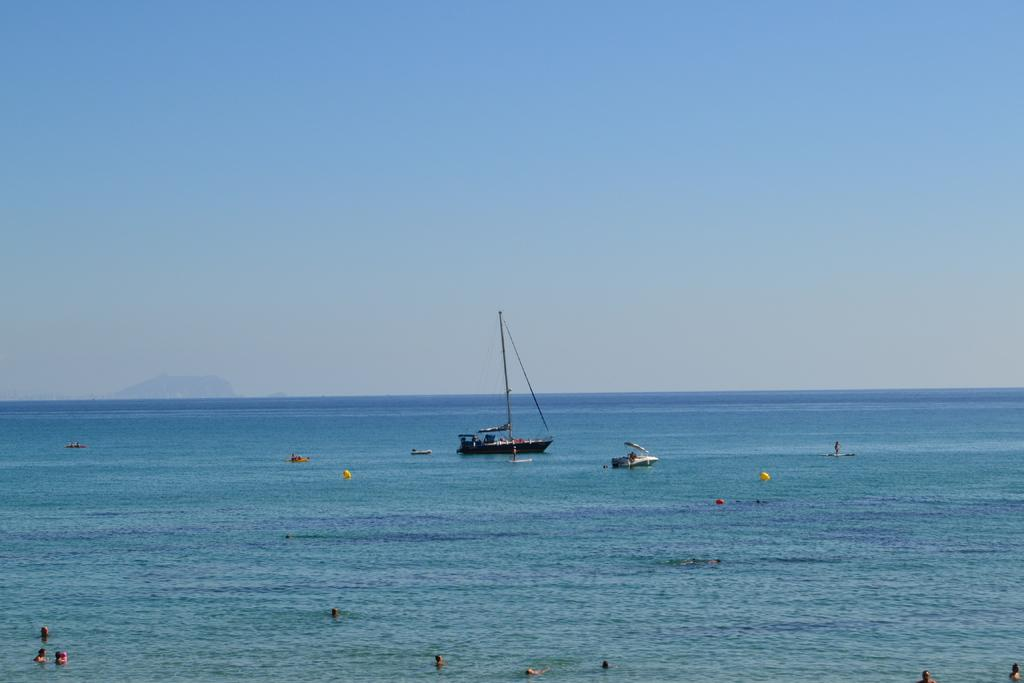Where was the image taken? The image is clicked outside the city. What can be seen in the foreground of the image? There is a group of people in the foreground. What is the location of the group of people in the image? The group of people is in a water body. What else can be seen in the image? There are boats in the center of the image. What is visible in the background of the image? The sky is visible in the background. How many dogs are present in the image? There are no dogs present in the image. What type of root can be seen growing near the water body? There is no root visible in the image; it features a group of people, boats, and a water body. 